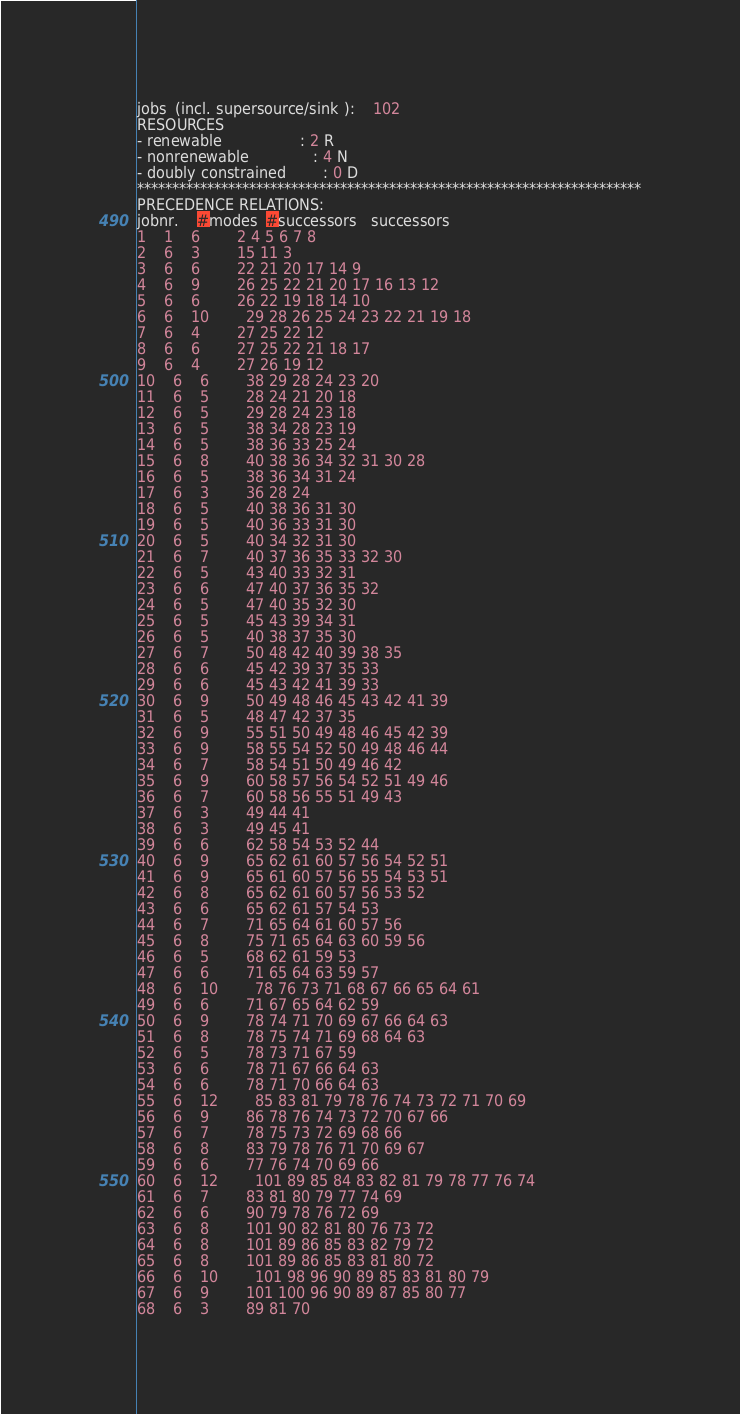Convert code to text. <code><loc_0><loc_0><loc_500><loc_500><_ObjectiveC_>jobs  (incl. supersource/sink ):	102
RESOURCES
- renewable                 : 2 R
- nonrenewable              : 4 N
- doubly constrained        : 0 D
************************************************************************
PRECEDENCE RELATIONS:
jobnr.    #modes  #successors   successors
1	1	6		2 4 5 6 7 8 
2	6	3		15 11 3 
3	6	6		22 21 20 17 14 9 
4	6	9		26 25 22 21 20 17 16 13 12 
5	6	6		26 22 19 18 14 10 
6	6	10		29 28 26 25 24 23 22 21 19 18 
7	6	4		27 25 22 12 
8	6	6		27 25 22 21 18 17 
9	6	4		27 26 19 12 
10	6	6		38 29 28 24 23 20 
11	6	5		28 24 21 20 18 
12	6	5		29 28 24 23 18 
13	6	5		38 34 28 23 19 
14	6	5		38 36 33 25 24 
15	6	8		40 38 36 34 32 31 30 28 
16	6	5		38 36 34 31 24 
17	6	3		36 28 24 
18	6	5		40 38 36 31 30 
19	6	5		40 36 33 31 30 
20	6	5		40 34 32 31 30 
21	6	7		40 37 36 35 33 32 30 
22	6	5		43 40 33 32 31 
23	6	6		47 40 37 36 35 32 
24	6	5		47 40 35 32 30 
25	6	5		45 43 39 34 31 
26	6	5		40 38 37 35 30 
27	6	7		50 48 42 40 39 38 35 
28	6	6		45 42 39 37 35 33 
29	6	6		45 43 42 41 39 33 
30	6	9		50 49 48 46 45 43 42 41 39 
31	6	5		48 47 42 37 35 
32	6	9		55 51 50 49 48 46 45 42 39 
33	6	9		58 55 54 52 50 49 48 46 44 
34	6	7		58 54 51 50 49 46 42 
35	6	9		60 58 57 56 54 52 51 49 46 
36	6	7		60 58 56 55 51 49 43 
37	6	3		49 44 41 
38	6	3		49 45 41 
39	6	6		62 58 54 53 52 44 
40	6	9		65 62 61 60 57 56 54 52 51 
41	6	9		65 61 60 57 56 55 54 53 51 
42	6	8		65 62 61 60 57 56 53 52 
43	6	6		65 62 61 57 54 53 
44	6	7		71 65 64 61 60 57 56 
45	6	8		75 71 65 64 63 60 59 56 
46	6	5		68 62 61 59 53 
47	6	6		71 65 64 63 59 57 
48	6	10		78 76 73 71 68 67 66 65 64 61 
49	6	6		71 67 65 64 62 59 
50	6	9		78 74 71 70 69 67 66 64 63 
51	6	8		78 75 74 71 69 68 64 63 
52	6	5		78 73 71 67 59 
53	6	6		78 71 67 66 64 63 
54	6	6		78 71 70 66 64 63 
55	6	12		85 83 81 79 78 76 74 73 72 71 70 69 
56	6	9		86 78 76 74 73 72 70 67 66 
57	6	7		78 75 73 72 69 68 66 
58	6	8		83 79 78 76 71 70 69 67 
59	6	6		77 76 74 70 69 66 
60	6	12		101 89 85 84 83 82 81 79 78 77 76 74 
61	6	7		83 81 80 79 77 74 69 
62	6	6		90 79 78 76 72 69 
63	6	8		101 90 82 81 80 76 73 72 
64	6	8		101 89 86 85 83 82 79 72 
65	6	8		101 89 86 85 83 81 80 72 
66	6	10		101 98 96 90 89 85 83 81 80 79 
67	6	9		101 100 96 90 89 87 85 80 77 
68	6	3		89 81 70 </code> 